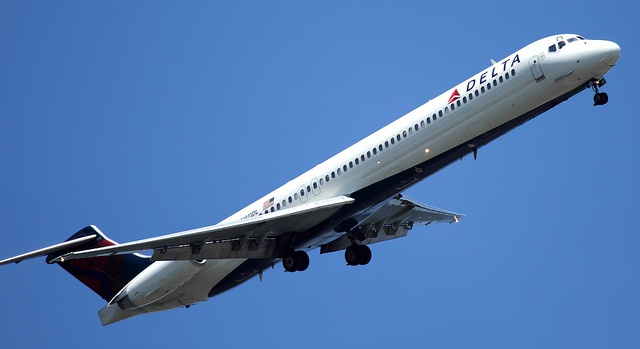Describe the objects in this image and their specific colors. I can see a airplane in blue, black, gray, and white tones in this image. 